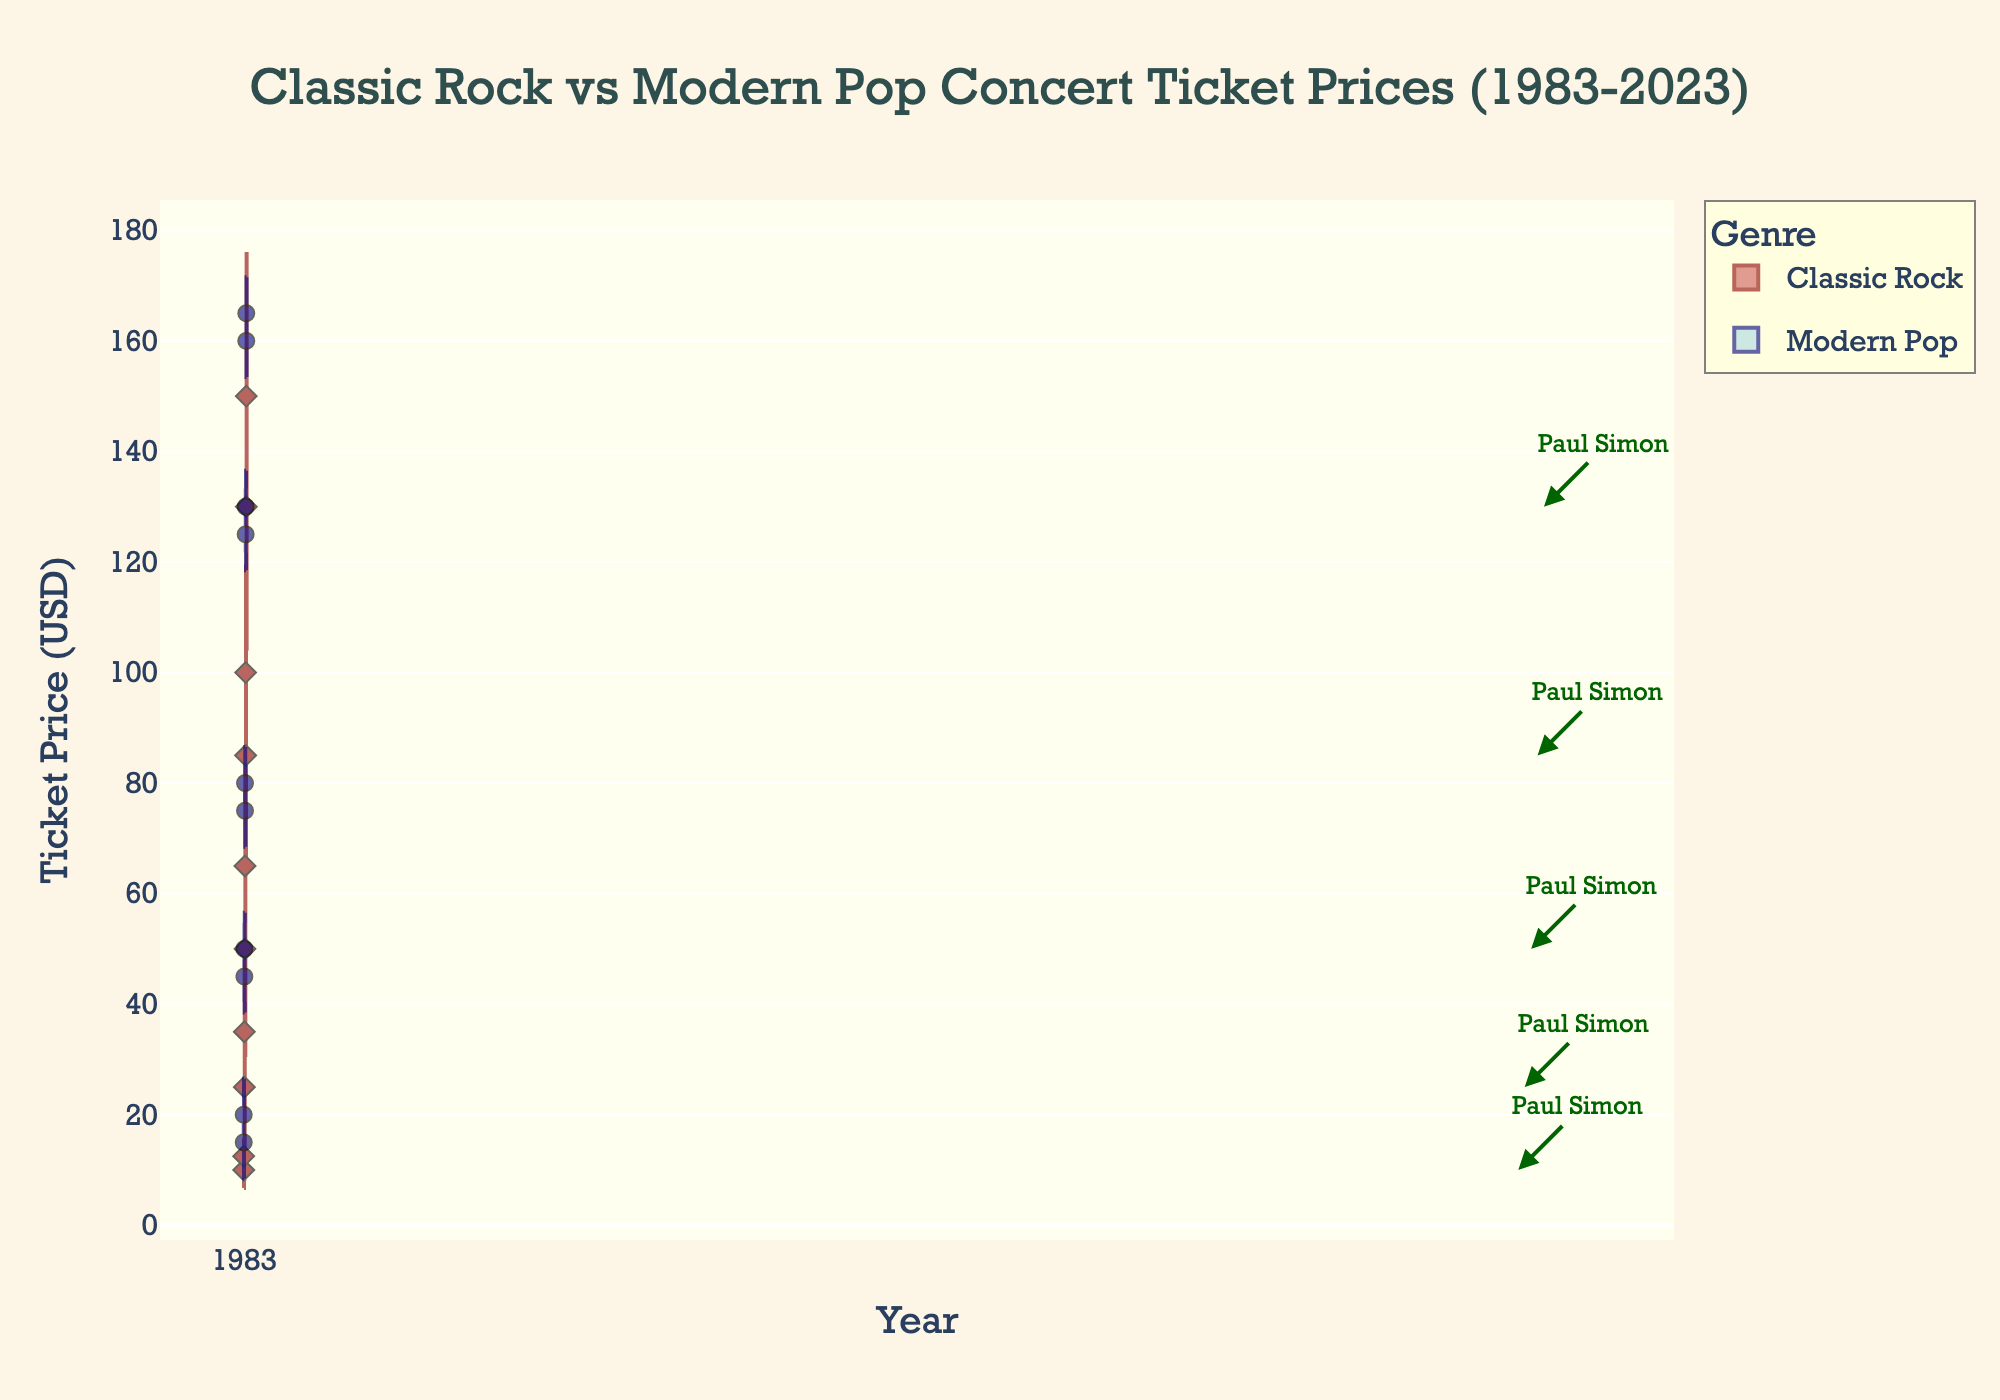What is the title of the figure? The title of the figure is usually located at the top center and is in a larger font size for emphasis. The title of the figure is "Classic Rock vs Modern Pop Concert Ticket Prices (1983-2023)" as seen at the top of the chart.
Answer: Classic Rock vs Modern Pop Concert Ticket Prices (1983-2023) Which genre has higher ticket prices in 2023? By observing the violin plots for 2023, the data points for Modern Pop are higher on the y-axis compared to Classic Rock. This indicates that Modern Pop has higher concert ticket prices.
Answer: Modern Pop What is the y-axis label? The y-axis label is typically found along the vertical axis of the chart. It indicates what is being measured on this axis. The y-axis label is "Ticket Price (USD)."
Answer: Ticket Price (USD) How have Paul Simon's ticket prices changed from 1983 to 2023? Look for annotations of Paul Simon's data points across the years. In 1983, his ticket price was $10.00, and in 2023, it was $130.00. Calculating the difference: $130.00 - $10.00 = $120.00.
Answer: +$120.00 Compare the median ticket prices of Classic Rock and Modern Pop in 2003. Identify the median line within the violin plots for both genres in 2003. The median for Classic Rock is around $50.00, while for Modern Pop, it's around $77.50.
Answer: Classic Rock: $50.00, Modern Pop: $77.50 What can you say about the ticket price distribution for Modern Pop in 1993? The violin plot for Modern Pop in 1993 is wider compared to other years, indicating a larger spread of ticket prices with values ranging from $45 to $50. This suggests significant variation in ticket prices for Modern Pop concerts in 1993.
Answer: Wide distribution, range $45-50 How does the ticket price range for Classic Rock compare between 2003 and 2023? Examine the spread of the violin plots for Classic Rock in 2003 and 2023. In 2003, the price ranges from approximately $50 to $65. In 2023, the range is from about $130 to $150.
Answer: 2003: $50-$65, 2023: $130-$150 What features are used to differentiate the genres in the figure? The figure uses distinct colors, shapes, and sides for differentiation: Classic Rock is represented with dark red color, diamond markers, and appears on the positive side, while Modern Pop uses navy color, circle markers, and appears on the negative side.
Answer: Colors, markers, sides Describe the trend of ticket prices from 1983 to 2023 for both genres. By observing the shift in the median lines and overall height of the violin plots over time for both genres, there is a noticeable upward trend for ticket prices from 1983 to 2023, suggesting that ticket prices for both genres have increased over the years.
Answer: Upward trend 